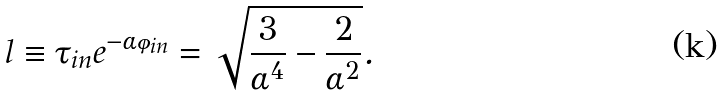Convert formula to latex. <formula><loc_0><loc_0><loc_500><loc_500>l \equiv \tau _ { i n } e ^ { - \alpha \varphi _ { i n } } = \sqrt { \frac { 3 } { \alpha ^ { 4 } } - \frac { 2 } { \alpha ^ { 2 } } } .</formula> 